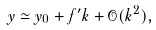Convert formula to latex. <formula><loc_0><loc_0><loc_500><loc_500>y \simeq y _ { 0 } + f ^ { \prime } k + \mathcal { O } ( k ^ { 2 } ) ,</formula> 